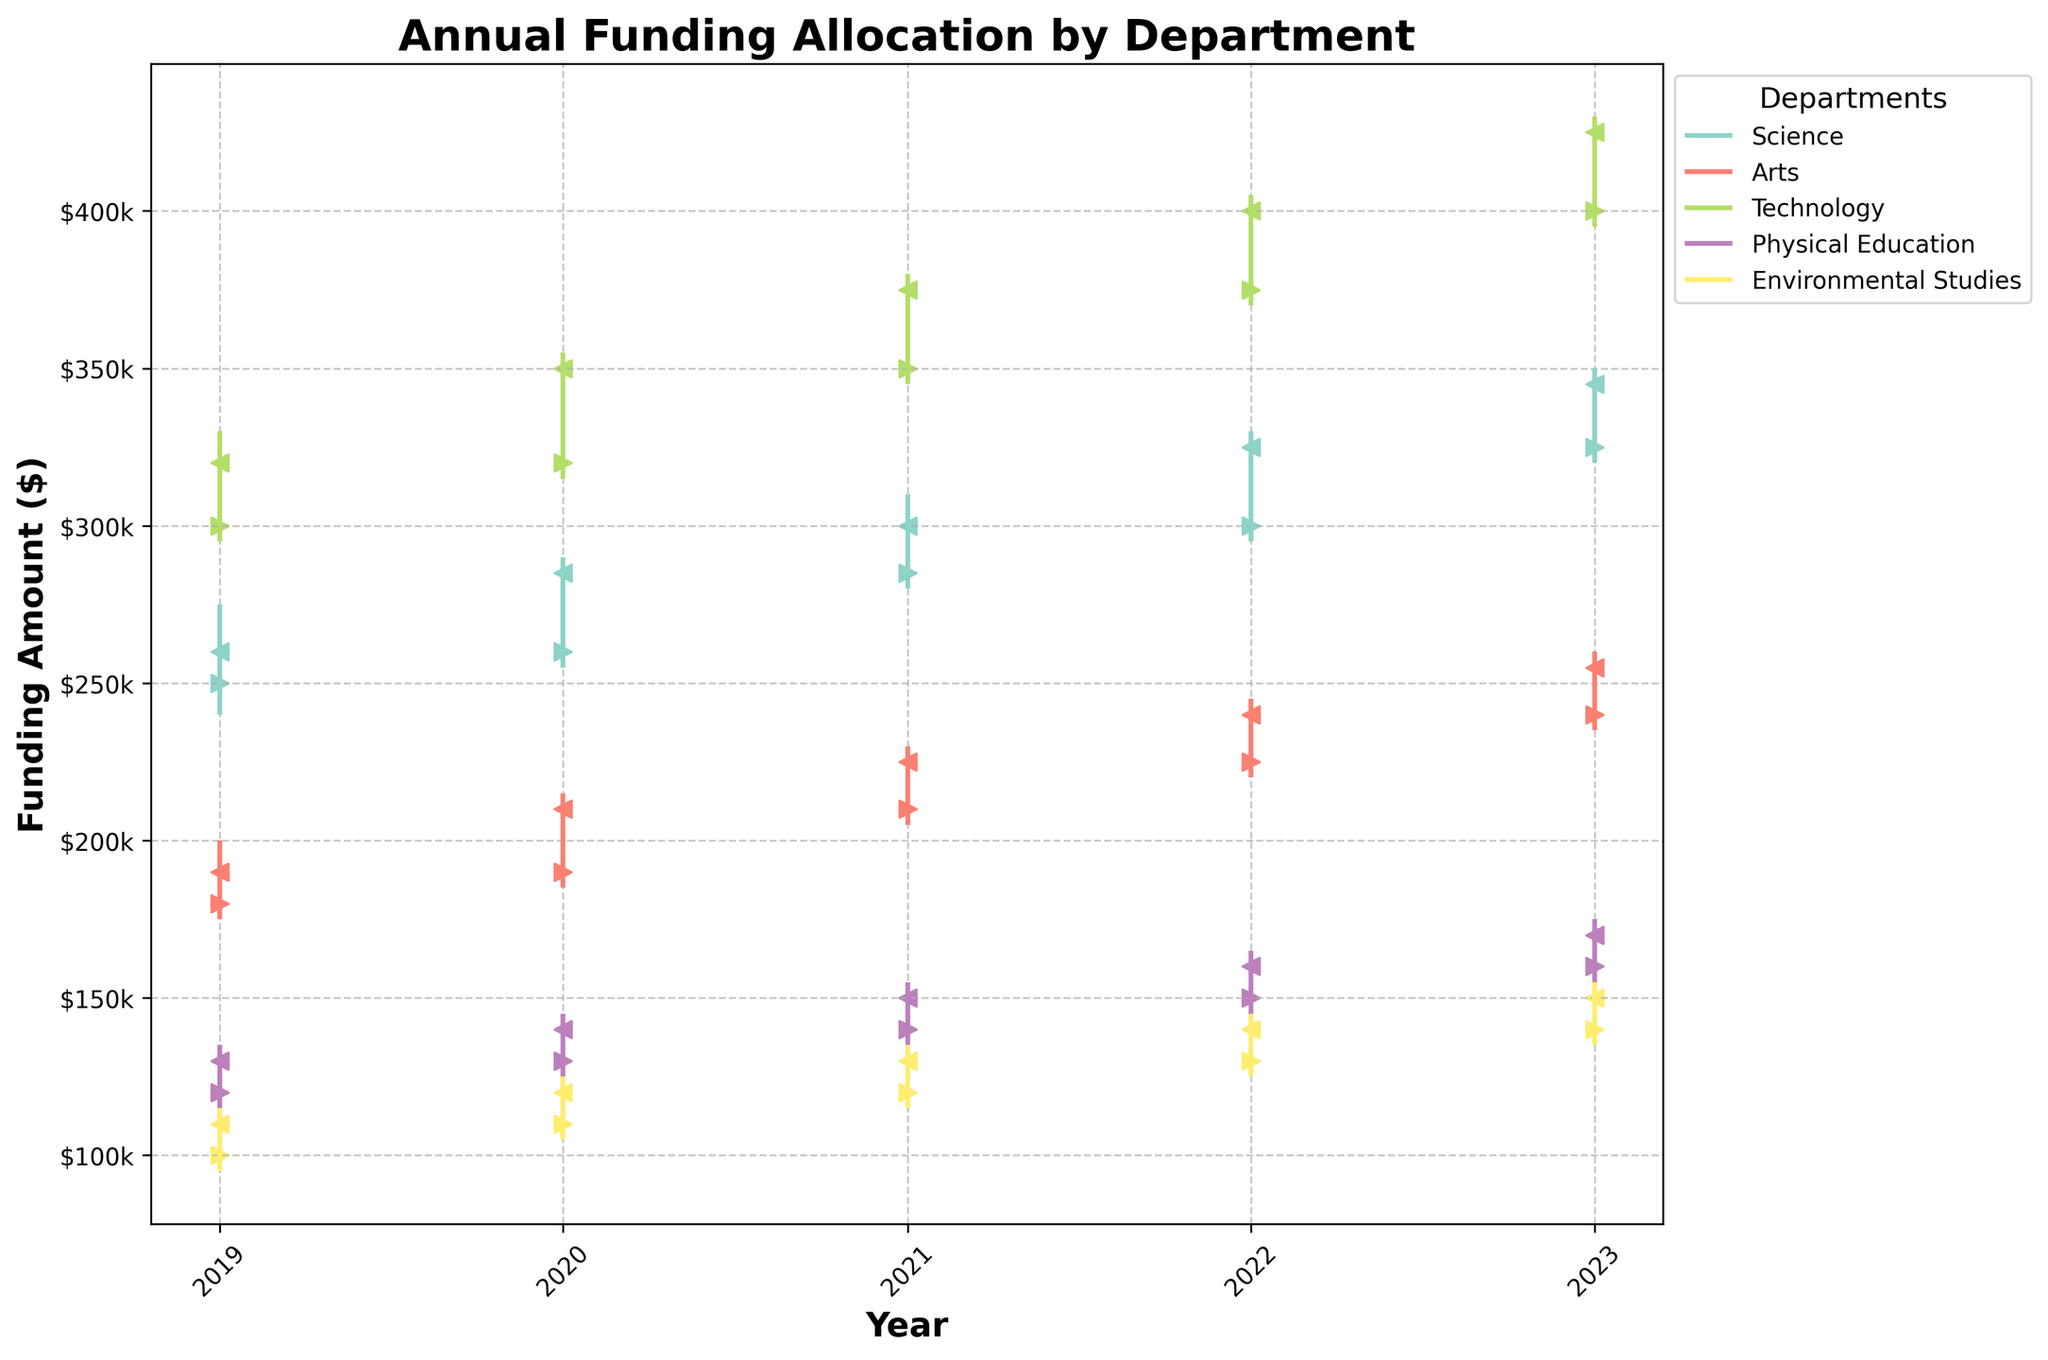What is the title of the chart? The text at the top of the chart indicates its title, which helps in understanding what the chart is about.
Answer: Annual Funding Allocation by Department Which department received the highest funding in 2023 at its peak? By observing the peaks for each department in 2023, we can see that the Technology department tops the others with funding peaking at $430,000.
Answer: Technology Which department shows the least increase in their yearly closing funding from 2019 to 2023? By calculating the difference in closing funding from 2019 to 2023 for each department, we find that Physical Education has the smallest increase: $170,000 - $130,000 = $40,000.
Answer: Physical Education How many departments are represented in this chart? By counting the number of different colors or labels in the legend, we can determine the number of departments.
Answer: 5 Compare the funding trends for the Science and Arts departments over the years. Which one had higher closing values in more years? By comparing the annual closing funding amounts, we see that Science consistently has higher closing values than Arts across all five years.
Answer: Science Between Environmental Studies and Physical Education, which department's funding crossed $150,000 earlier, and in which year did it happen? By noting the years when each department's funding crossed the $150,000 mark, we see Environmental Studies first hit $150,000 in 2023, the same year Physical Education did.
Answer: Both in 2023 What was the maximum funding amount reached by the Arts department in any year? By checking the 'High' column for the Arts department over the five years, the highest amount was in 2023 at $260,000.
Answer: $260,000 Calculate the overall average of the closing funding for all departments over the years, and identify which year had the highest average closing funding. Summing the closing values of all departments for each year and calculating their average shows that 2023 had the highest average closing funding.
Answer: 2023 What is the trend in Technology department's funding from 2019 to 2023 in terms of opening values? By tracking the 'Open' values for the Technology department from 2019 ($300,000) to 2023 ($400,000), we see a steady increase each year.
Answer: Upward trend 